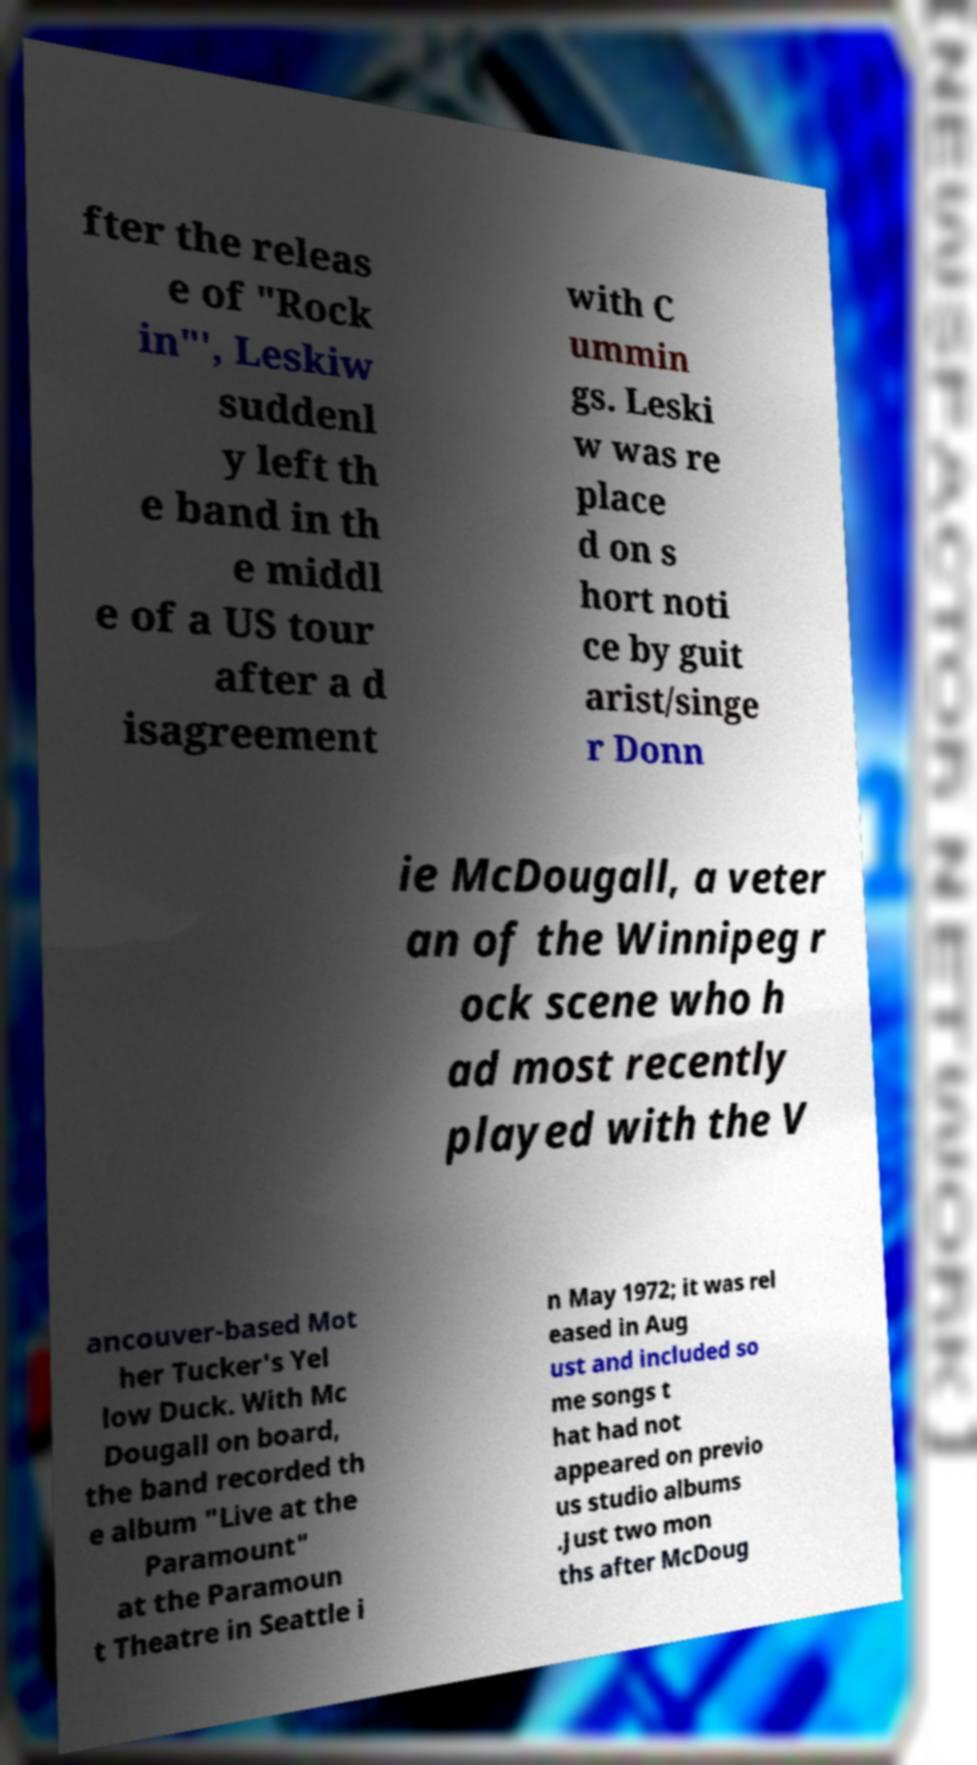Can you accurately transcribe the text from the provided image for me? fter the releas e of "Rock in"', Leskiw suddenl y left th e band in th e middl e of a US tour after a d isagreement with C ummin gs. Leski w was re place d on s hort noti ce by guit arist/singe r Donn ie McDougall, a veter an of the Winnipeg r ock scene who h ad most recently played with the V ancouver-based Mot her Tucker's Yel low Duck. With Mc Dougall on board, the band recorded th e album "Live at the Paramount" at the Paramoun t Theatre in Seattle i n May 1972; it was rel eased in Aug ust and included so me songs t hat had not appeared on previo us studio albums .Just two mon ths after McDoug 